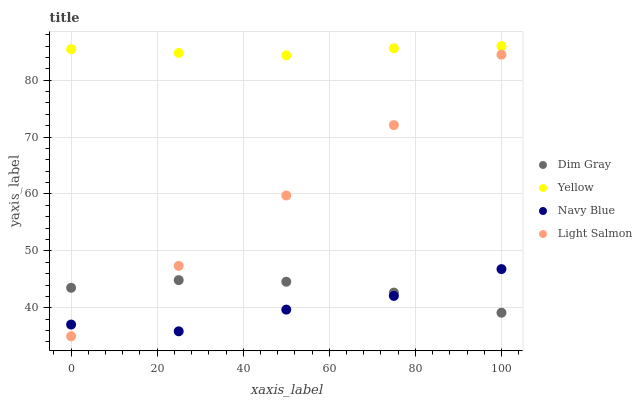Does Navy Blue have the minimum area under the curve?
Answer yes or no. Yes. Does Yellow have the maximum area under the curve?
Answer yes or no. Yes. Does Light Salmon have the minimum area under the curve?
Answer yes or no. No. Does Light Salmon have the maximum area under the curve?
Answer yes or no. No. Is Light Salmon the smoothest?
Answer yes or no. Yes. Is Navy Blue the roughest?
Answer yes or no. Yes. Is Dim Gray the smoothest?
Answer yes or no. No. Is Dim Gray the roughest?
Answer yes or no. No. Does Light Salmon have the lowest value?
Answer yes or no. Yes. Does Dim Gray have the lowest value?
Answer yes or no. No. Does Yellow have the highest value?
Answer yes or no. Yes. Does Light Salmon have the highest value?
Answer yes or no. No. Is Navy Blue less than Yellow?
Answer yes or no. Yes. Is Yellow greater than Dim Gray?
Answer yes or no. Yes. Does Light Salmon intersect Dim Gray?
Answer yes or no. Yes. Is Light Salmon less than Dim Gray?
Answer yes or no. No. Is Light Salmon greater than Dim Gray?
Answer yes or no. No. Does Navy Blue intersect Yellow?
Answer yes or no. No. 